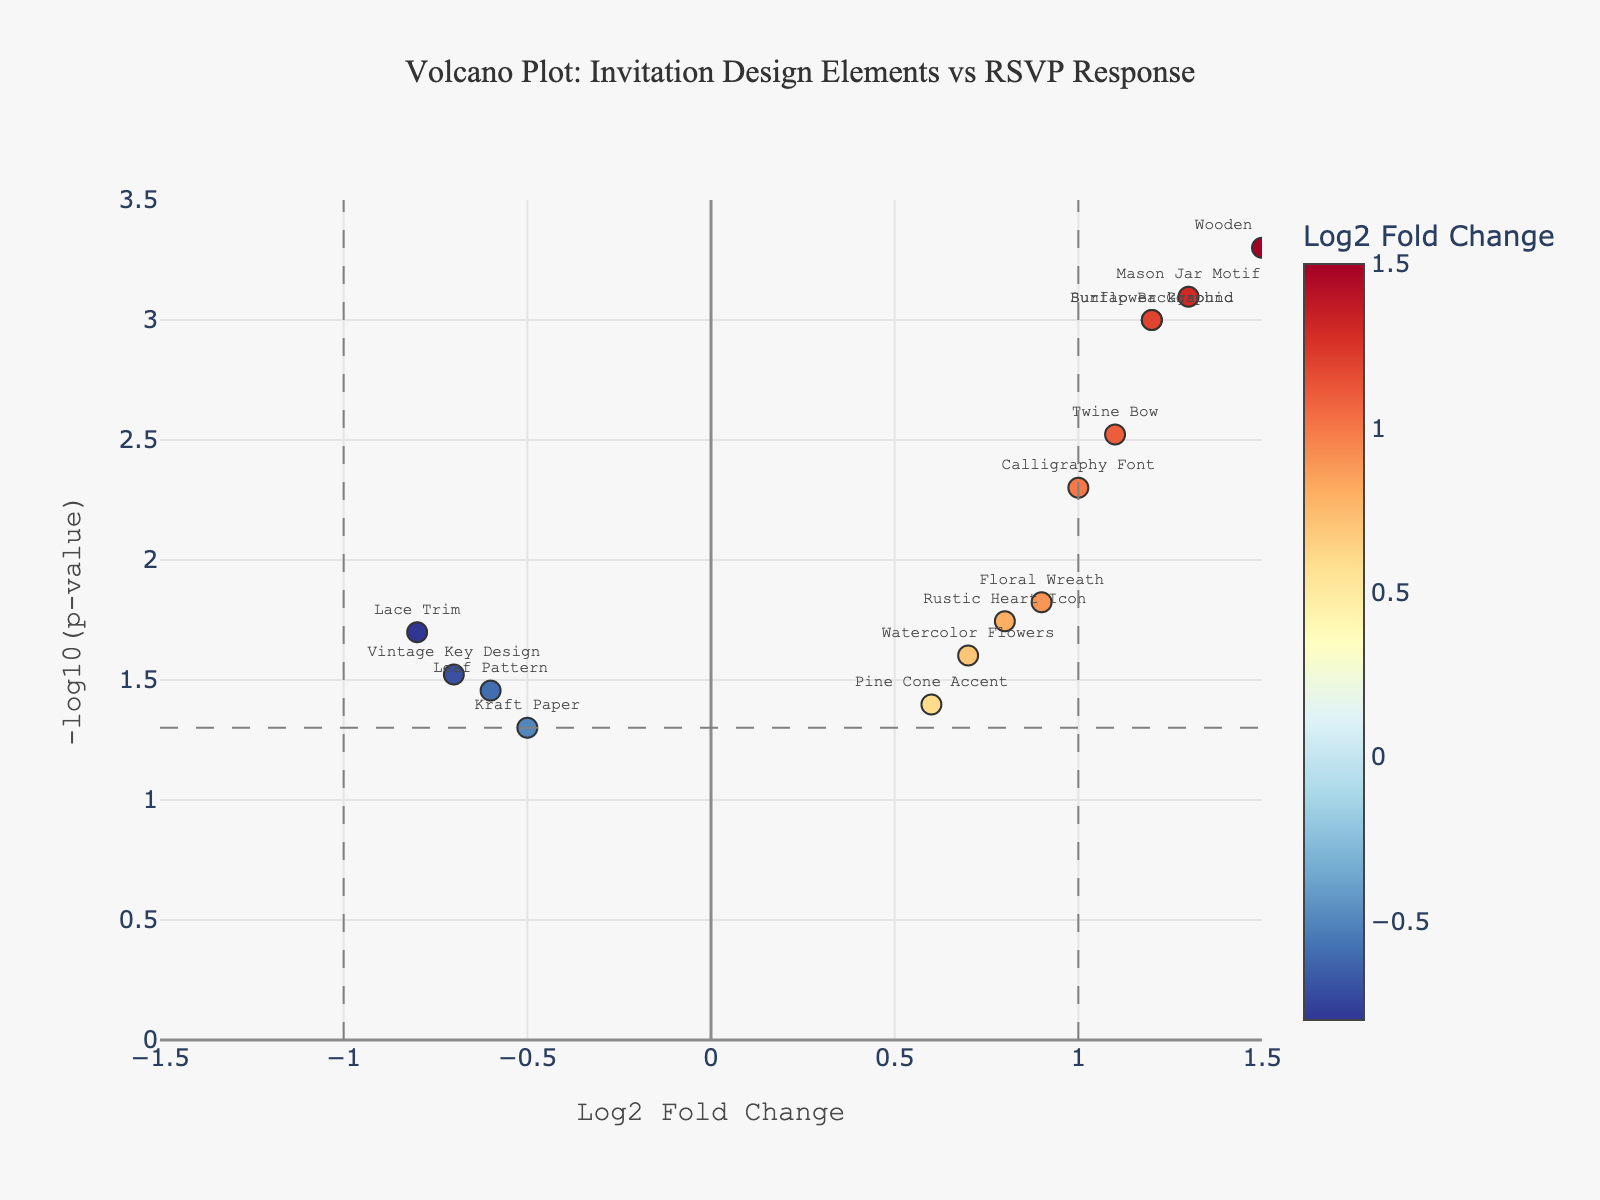How many design elements have a positive log2 fold change? Count the number of points to the right of the y-axis (log2 fold change > 0). The points include Burlap Background, Wooden Texture, Floral Wreath, Twine Bow, Watercolor Flowers, Mason Jar Motif, Barn Wood Frame, Calligraphy Font, Rustic Heart Icon, and Sunflower Graphic.
Answer: 10 Which design element has the highest -log10(p-value)? Find the point with the highest y-axis value. The highest -log10(p-value) corresponds to the Barn Wood Frame.
Answer: Barn Wood Frame Are there any elements that have a negative log2 fold change and a -log10(p-value) above 1.30? Look for points to the left of the y-axis (log2 fold change < 0) and check if any have a y-axis (-log10(p-value)) value greater than 1.30. Specifically, consider the Lace Trim (-0.8, 1.70), Kraft Paper (-0.5, 1.30), Leaf Pattern (-0.6, 1.40), and Vintage Key Design (-0.7, 1.52).
Answer: Yes What is the log2 fold change for the design element with the lowest p-value? The lowest p-value corresponds to the highest -log10(p-value), which is Barn Wood Frame. The log2 fold change for Barn Wood Frame is 1.4.
Answer: 1.4 Compare the log2 fold changes of the Burlap Background and the Mason Jar Motif. Which is higher and by how much? The log2 fold change for Burlap Background is 1.2, and for Mason Jar Motif, it is 1.3. Subtract Burlap Background's value from Mason Jar Motif's value: 1.3 - 1.2 = 0.1.
Answer: Mason Jar Motif by 0.1 What is the difference in -log10(p-value) between the Wooden Texture and the Kraft Paper? The -log10(p-value) for Wooden Texture is -log10(0.0005) ≈ 3.30, and for Kraft Paper, it is -log10(0.05) ≈ 1.30. Subtract Kraft Paper's value from Wooden Texture's value: 3.30 - 1.30 = 2.00.
Answer: 2.00 Which design element with a negative log2 fold change has the highest -log10(p-value)? Among the elements with a negative log2 fold change, find the one with the highest y-axis value. The Vintage Key Design has the highest -log10(p-value).
Answer: Vintage Key Design Identify the design elements that fall below the horizontal threshold line at -log10(p-value) = 1.30. Look for points with y-axis values below 1.30. These include Kraft Paper (1.30), Watercolor Flowers (1.60), Pine Cone Accent (1.40), and Leaf Pattern (1.40).
Answer: Kraft Paper, Watercolor Flowers, Pine Cone Accent, Leaf Pattern Which design elements show a statistically significant positive correlation with the RSVP response rates? Look for points to the right of the y-axis (positive log2 fold change) with a y-axis value ≥ 1.30 (-log10(0.05)). These are Burlap Background, Wooden Texture, Floral Wreath, Twine Bow, Mason Jar Motif, Barn Wood Frame, Calligraphy Font, Rustic Heart Icon, and Sunflower Graphic.
Answer: 9 